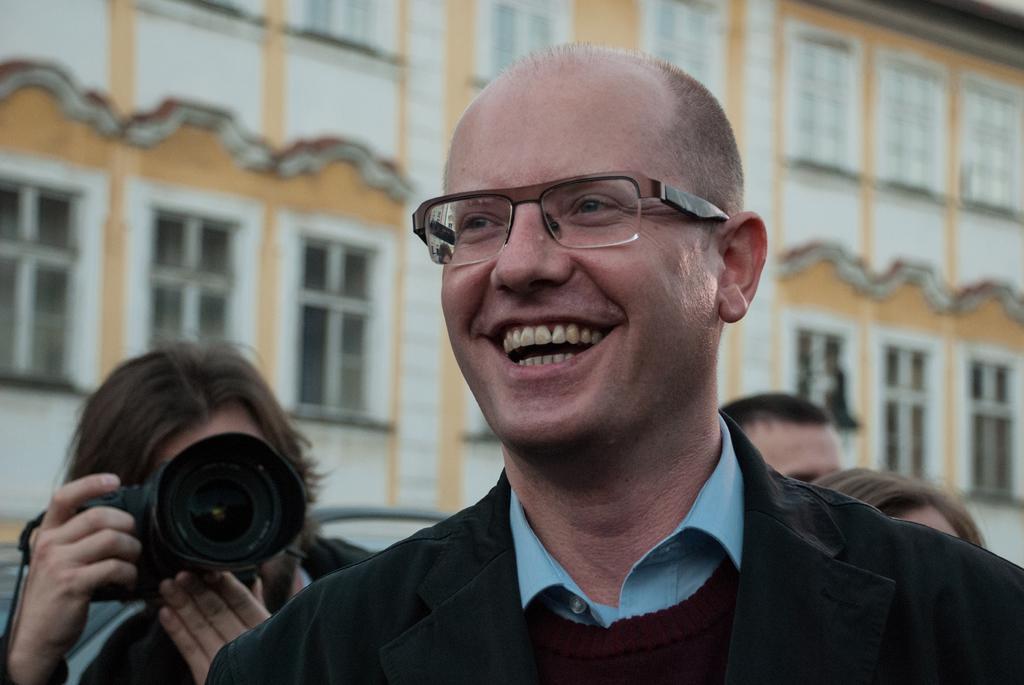In one or two sentences, can you explain what this image depicts? In this image there is a person with black dress is smiling and at the back there is a person holding camera. At the back there is a building with white color. 